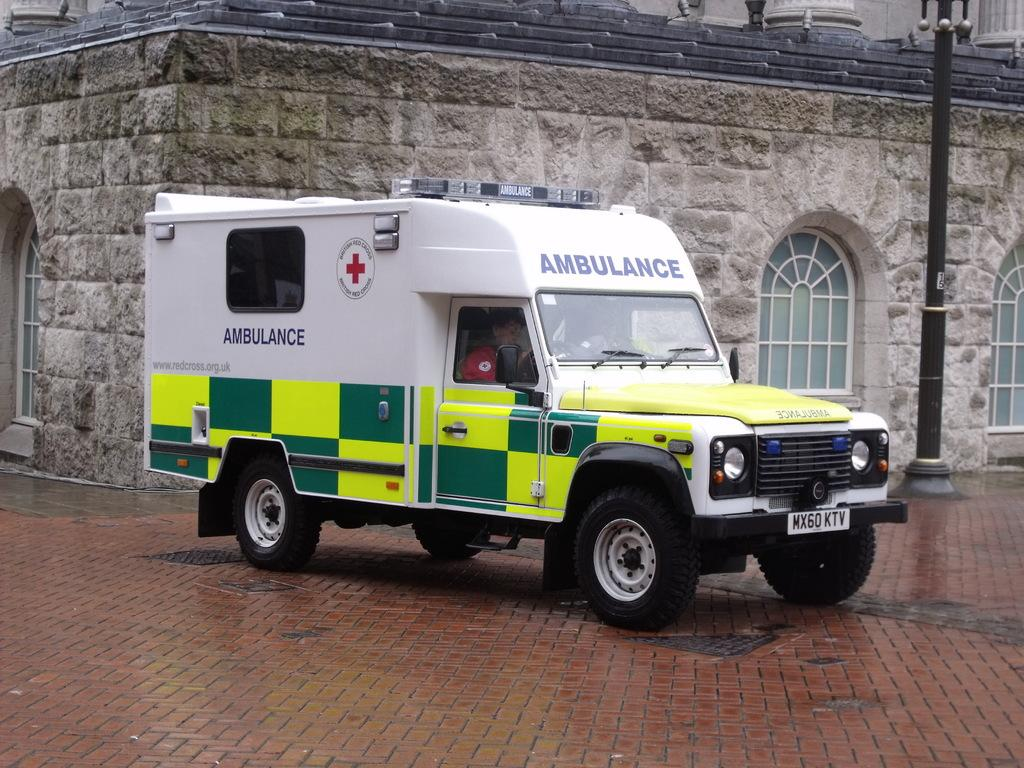What is the main subject of the image? The main subject of the image is an ambulance. Where is the ambulance located in the image? The ambulance is on the road in the image. What can be seen behind the ambulance? There is a building behind the ambulance in the image. What is present on the right side of the image? There is an electric pole on the right side of the image. How many boats are visible in the image? There are no boats present in the image; it features an ambulance on the road. What type of vessel is being used for learning in the image? There is no vessel or learning activity depicted in the image. 